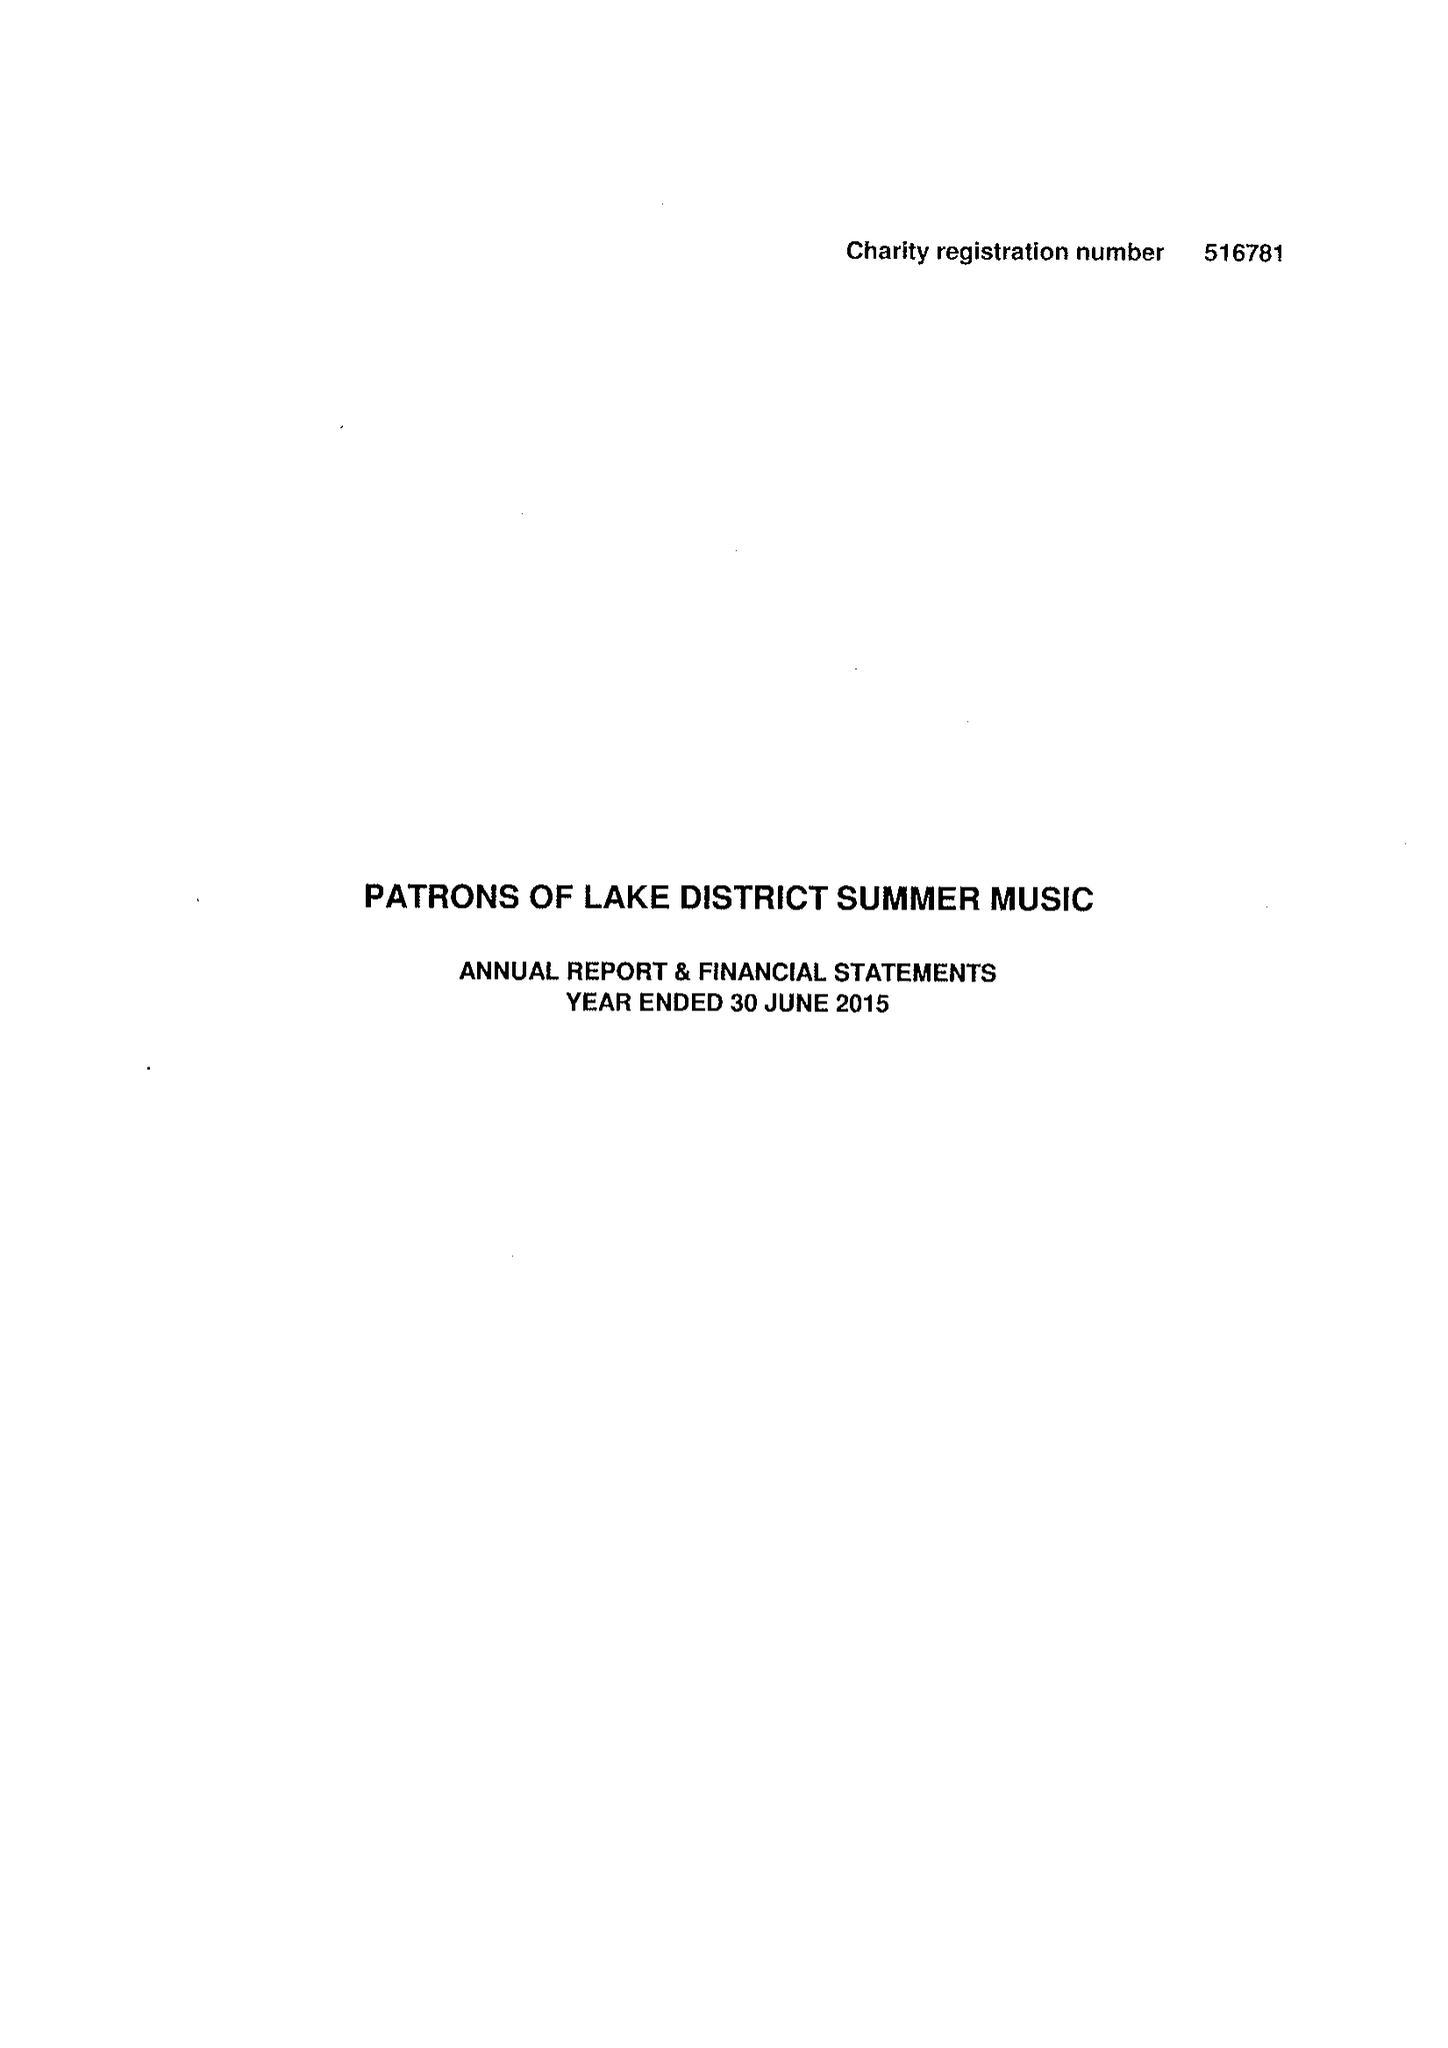What is the value for the charity_number?
Answer the question using a single word or phrase. 516781 